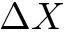<formula> <loc_0><loc_0><loc_500><loc_500>\Delta X</formula> 